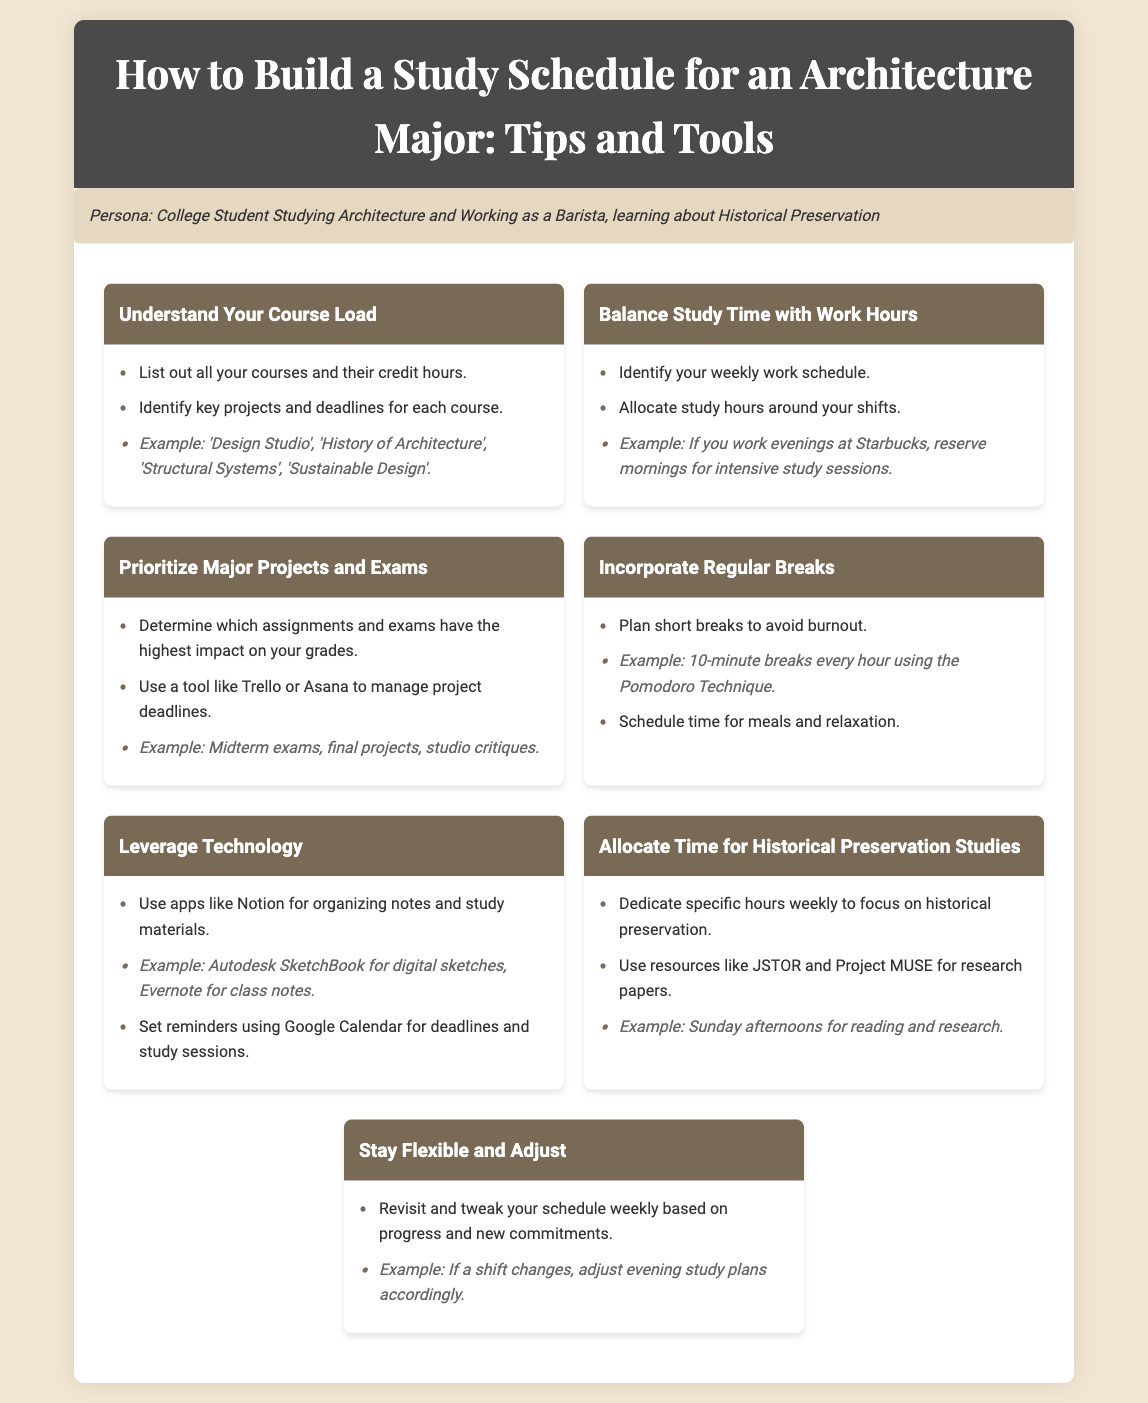what is the first section about? The first section discusses understanding the course load for architecture students.
Answer: Understand Your Course Load how should a student balance study time? The document suggests allocating study hours around work shifts to balance both.
Answer: Balance Study Time with Work Hours which project management tools are recommended? The document mentions using Trello or Asana for managing project deadlines.
Answer: Trello or Asana what is a technique suggested for taking breaks? The document suggests using the Pomodoro Technique for planning short breaks.
Answer: Pomodoro Technique what resource is recommended for historical preservation studies? The document suggests using JSTOR and Project MUSE for research papers.
Answer: JSTOR and Project MUSE how often should you adjust your study schedule? The document recommends revisiting and tweaking your schedule weekly.
Answer: Weekly what is an example of a class mentioned in the course load? The document provides 'Design Studio' as an example of a class.
Answer: Design Studio what is an example of a digital sketch tool? The document mentions Autodesk SketchBook as an example of a digital sketch tool.
Answer: Autodesk SketchBook what type of breaks are suggested for avoiding burnout? The document suggests planning short breaks.
Answer: Short breaks 